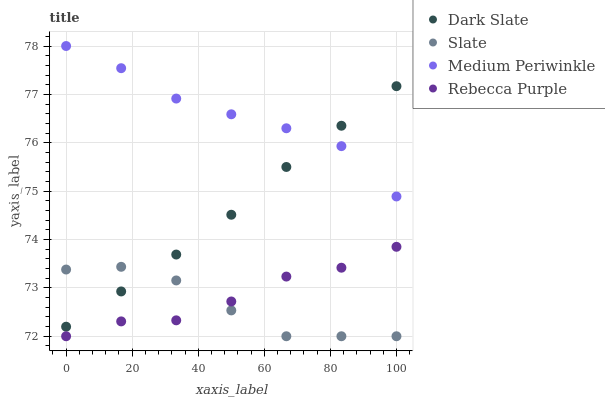Does Slate have the minimum area under the curve?
Answer yes or no. Yes. Does Medium Periwinkle have the maximum area under the curve?
Answer yes or no. Yes. Does Medium Periwinkle have the minimum area under the curve?
Answer yes or no. No. Does Slate have the maximum area under the curve?
Answer yes or no. No. Is Dark Slate the smoothest?
Answer yes or no. Yes. Is Rebecca Purple the roughest?
Answer yes or no. Yes. Is Slate the smoothest?
Answer yes or no. No. Is Slate the roughest?
Answer yes or no. No. Does Slate have the lowest value?
Answer yes or no. Yes. Does Medium Periwinkle have the lowest value?
Answer yes or no. No. Does Medium Periwinkle have the highest value?
Answer yes or no. Yes. Does Slate have the highest value?
Answer yes or no. No. Is Rebecca Purple less than Medium Periwinkle?
Answer yes or no. Yes. Is Dark Slate greater than Rebecca Purple?
Answer yes or no. Yes. Does Dark Slate intersect Slate?
Answer yes or no. Yes. Is Dark Slate less than Slate?
Answer yes or no. No. Is Dark Slate greater than Slate?
Answer yes or no. No. Does Rebecca Purple intersect Medium Periwinkle?
Answer yes or no. No. 